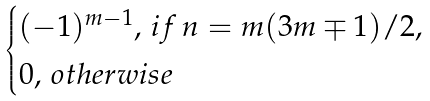<formula> <loc_0><loc_0><loc_500><loc_500>\begin{cases} ( - 1 ) ^ { m - 1 } , \, i f \, n = m ( 3 m \mp 1 ) / 2 , \\ 0 , \, o t h e r w i s e \end{cases}</formula> 